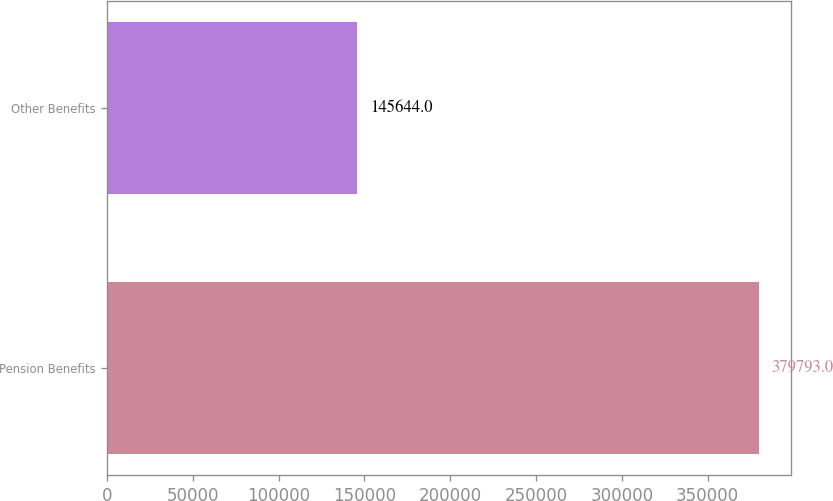Convert chart to OTSL. <chart><loc_0><loc_0><loc_500><loc_500><bar_chart><fcel>Pension Benefits<fcel>Other Benefits<nl><fcel>379793<fcel>145644<nl></chart> 